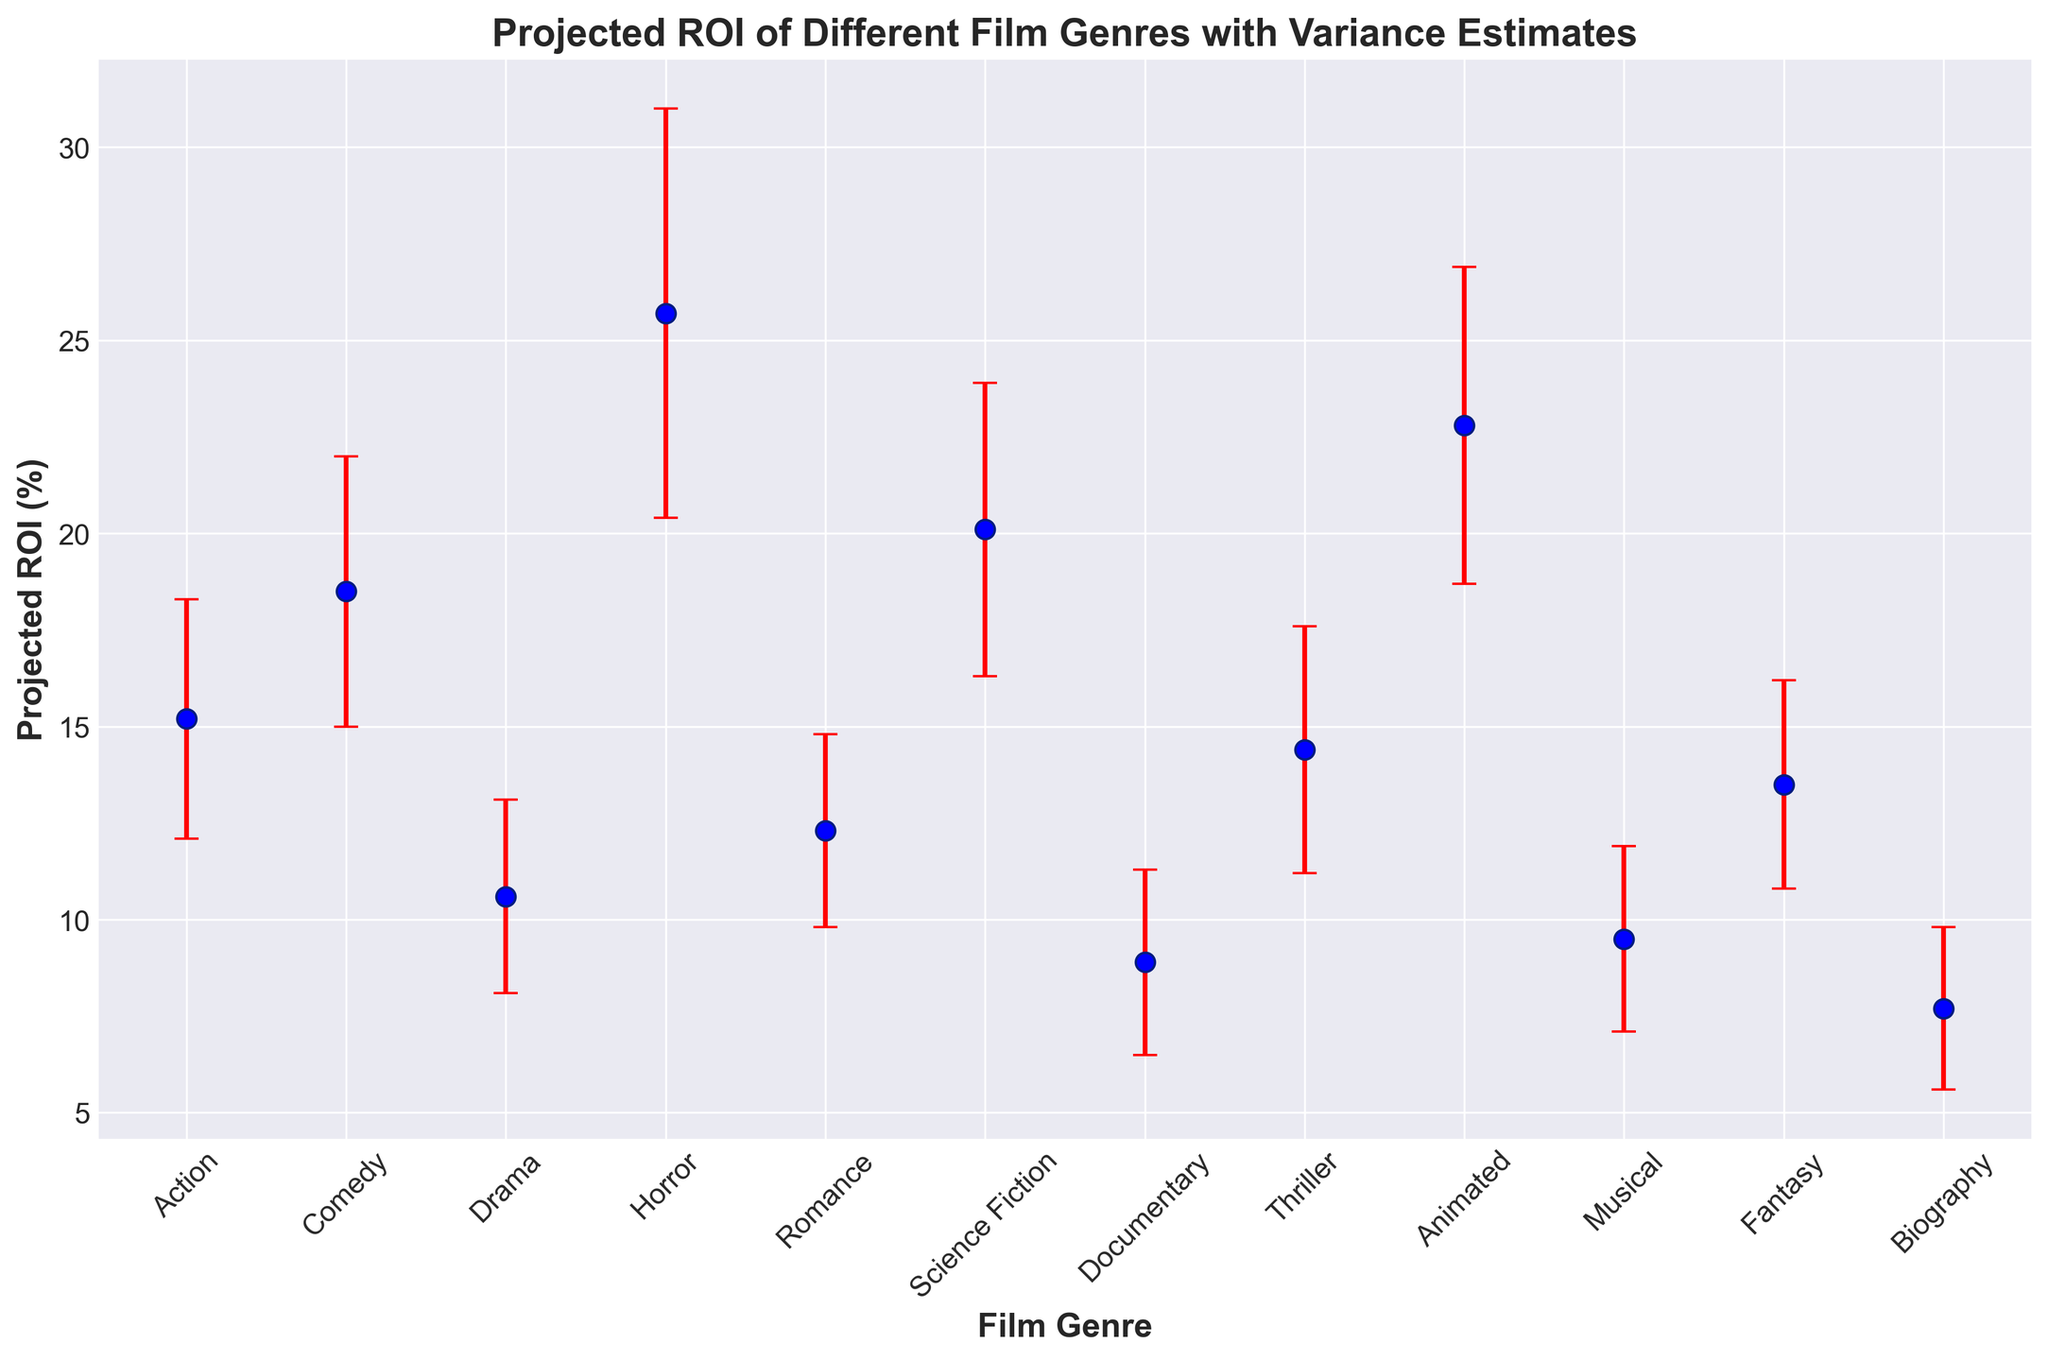Which film genre has the highest projected ROI? To determine the genre with the highest projected ROI, we look at the data points and find the highest value for projected ROI, which is 25.7% for Horror.
Answer: Horror Which two film genres have projected ROIs closest to each other? To find the genres with the closest projected ROIs, compare the listed values: Drama (10.6%) and Romance (12.3%) are the closest, with a difference of 1.7%.
Answer: Drama and Romance What's the range of projected ROIs for Action films? The range is calculated by subtracting the lower variance from the upper variance for Action films, which is 18.3% - 12.1% = 6.2%.
Answer: 6.2% Which genre has the largest variance in projected ROI? To find the genre with the largest variance, compare the differences between upper and lower variances for all genres. Horror has the largest variance, with a difference of 31.0% - 20.4% = 10.6%.
Answer: Horror How does the projected ROI for Animated films compare to Science Fiction films? Compare the projected ROI values: Animated (22.8%) is higher than Science Fiction (20.1%).
Answer: Animated is higher What is the average projected ROI of Comedy, Romance, and Action films? Calculate the average by summing the projected ROIs of Comedy (18.5%), Romance (12.3%), and Action (15.2%) and dividing by 3: (18.5 + 12.3 + 15.2) / 3 = 15.33%.
Answer: 15.33% Which genre shows the lowest projected ROI? The lowest projected ROI is 7.7% for Biography, as it is the smallest value among the projected ROIs.
Answer: Biography What is the difference in projected ROI between the highest and the lowest genres? Subtract the lowest projected ROI from the highest: 25.7% (Horror) - 7.7% (Biography) = 18%.
Answer: 18% Which genres have a projected ROI above 20%? Identify genres with projected ROI greater than 20%: Horror (25.7%), Science Fiction (20.1%), and Animated (22.8%).
Answer: Horror, Science Fiction, and Animated Which genre's projected ROI lies within the range of 10% to 15%? Identify genres within 10% to 15%: Drama (10.6%), Thriller (14.4%), Romance (12.3%), Action (15.2%, slightly above), and Fantasy (13.5%).
Answer: Drama, Thriller, Romance, Fantasy 